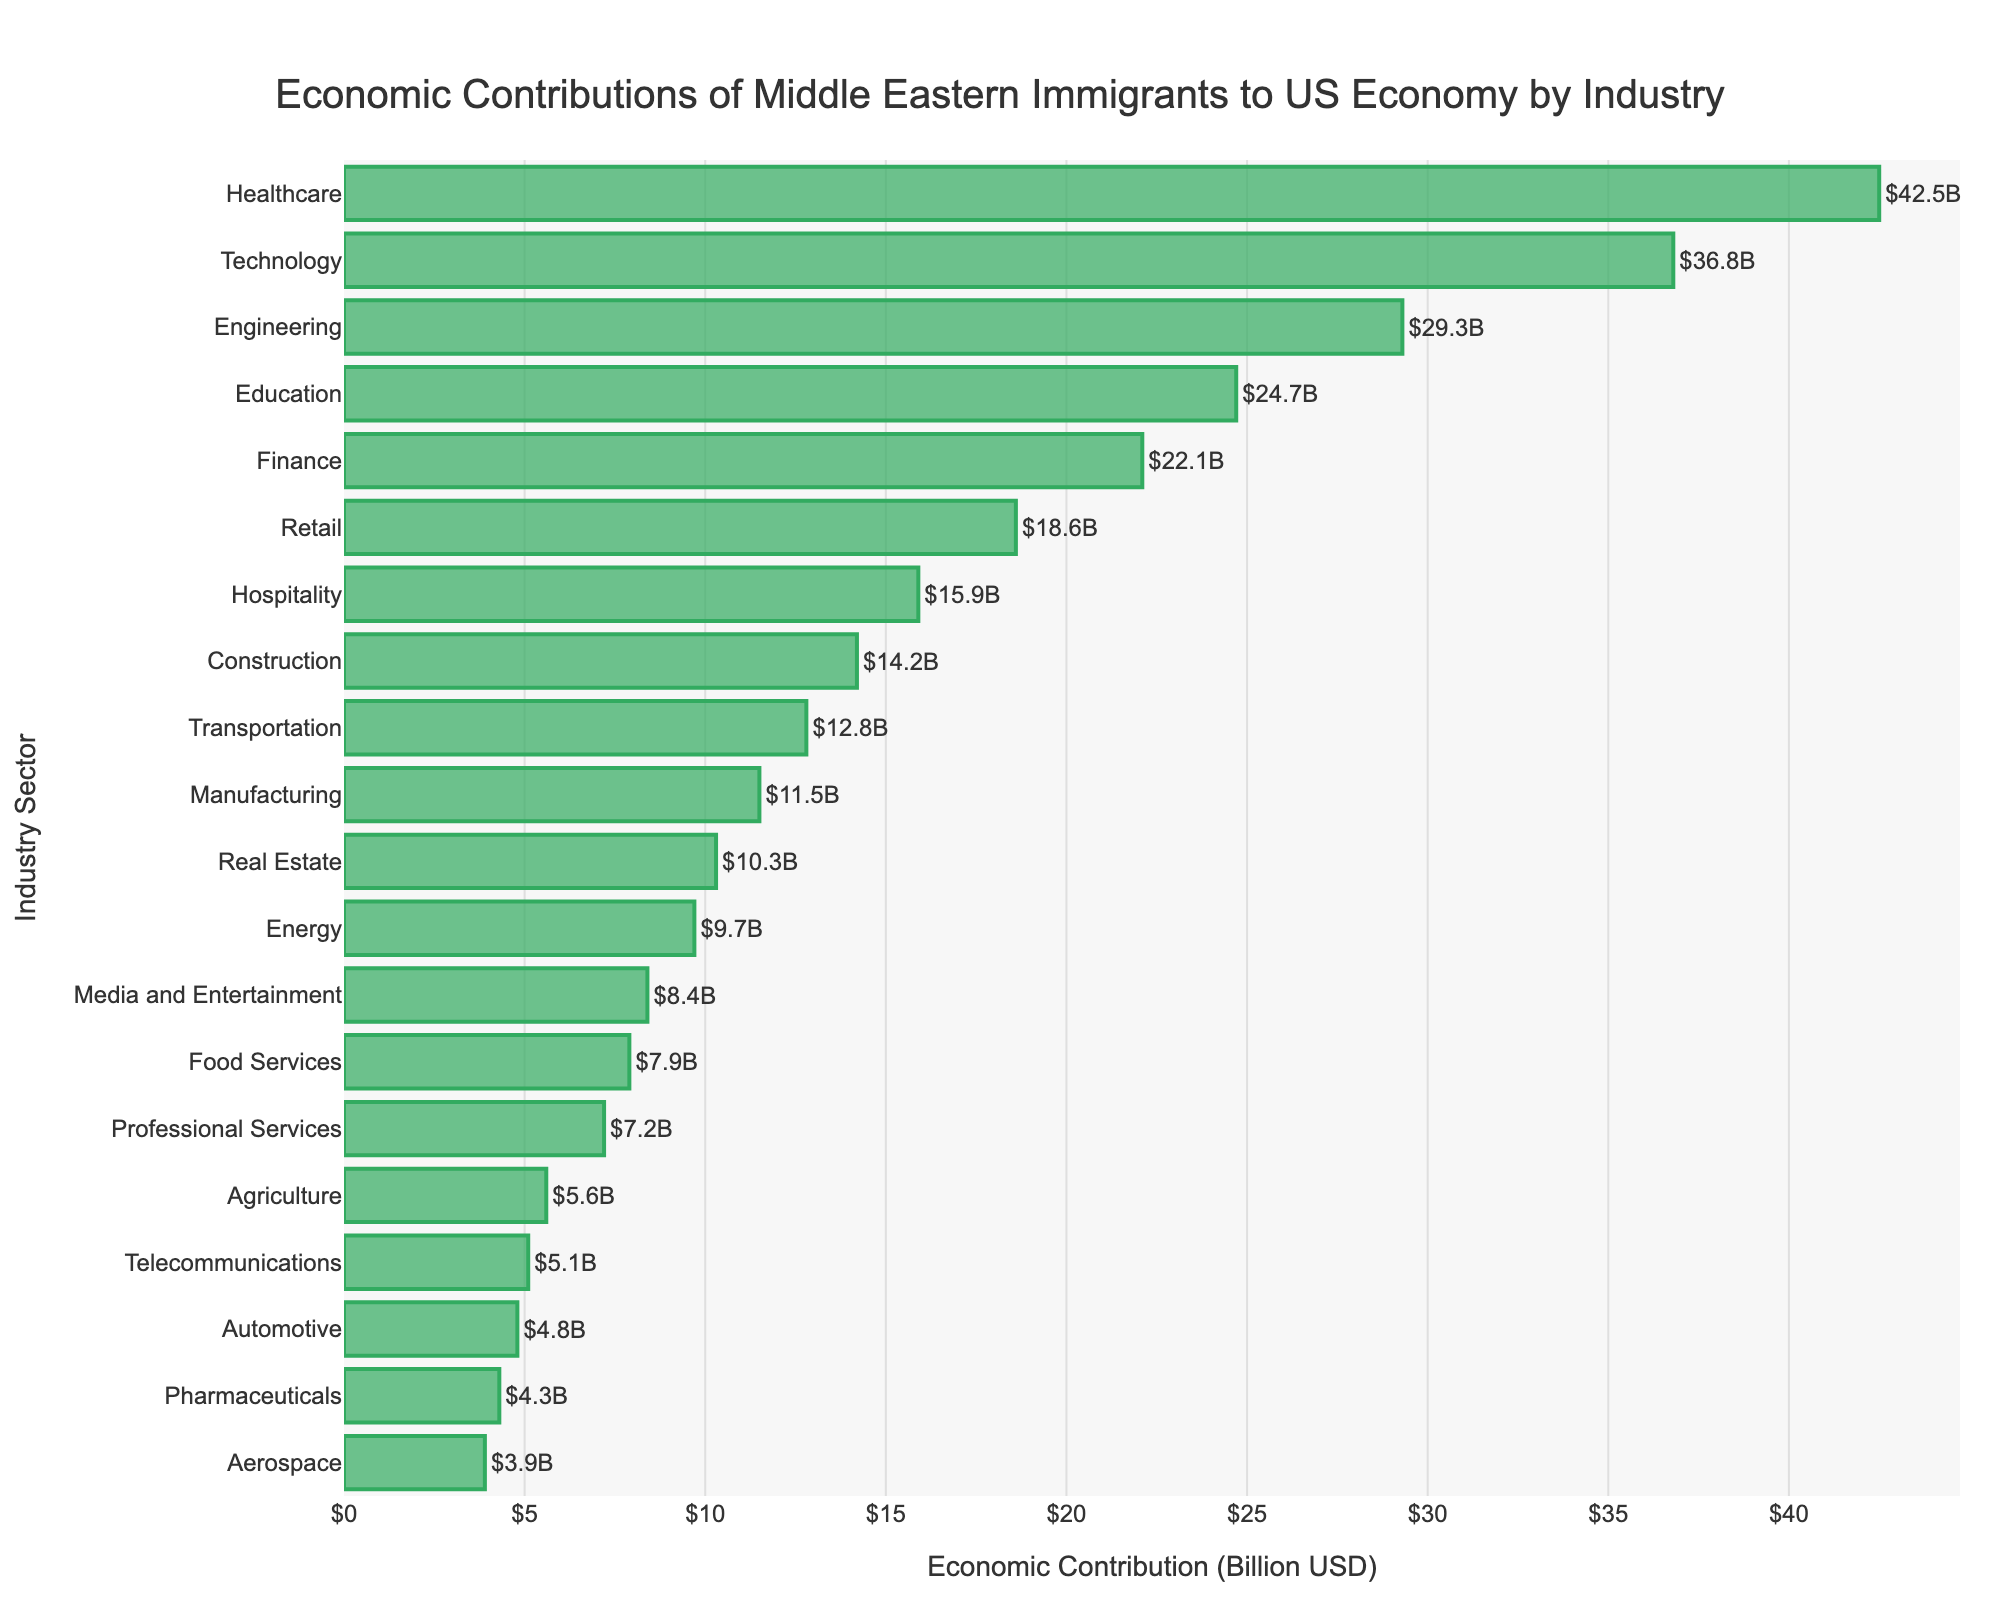Which industry has the highest economic contribution? The industry with the largest bar represents the highest economic contribution. The tallest bar corresponds to the Healthcare sector.
Answer: Healthcare What is the total economic contribution of the top three industries combined? The top three industries are Healthcare ($42.5B), Technology ($36.8B), and Engineering ($29.3B). Summing these values, $42.5B + $36.8B + $29.3B = $108.6B.
Answer: $108.6B Which industry has a higher economic contribution: Finance or Retail? By comparing the lengths of the bars corresponding to Finance and Retail, it is evident that Finance ($22.1B) is higher than Retail ($18.6B).
Answer: Finance What is the average economic contribution of the bottom five industries? The bottom five industries are Aerospace ($3.9B), Pharmaceuticals ($4.3B), Automotive ($4.8B), Telecommunications ($5.1B), and Agriculture ($5.6B). Sum these values: $3.9B + $4.3B + $4.8B + $5.1B + $5.6B = $23.7B. The average is $23.7B / 5 = $4.74B.
Answer: $4.74B Is the economic contribution of Technology greater than the combined contributions of Media and Entertainment and Food Services? The economic contribution of Technology is $36.8B. The combined contributions of Media and Entertainment ($8.4B) and Food Services ($7.9B) is $8.4B + $7.9B = $16.3B. Since $36.8B > $16.3B, Technology's contribution is greater.
Answer: Yes What is the difference in economic contributions between Education and Manufacturing? The economic contribution of Education is $24.7B and Manufacturing is $11.5B. The difference is $24.7B - $11.5B = $13.2B.
Answer: $13.2B How many industry sectors have an economic contribution of over $20 billion? By visually inspecting the bars longer than $20 billion, they are Healthcare, Technology, Engineering, Education, Finance. Therefore, there are 5 sectors.
Answer: 5 Which industry contributes more to the economy: Construction or Transportation? By comparing the bar lengths, Construction contributes $14.2B and Transportation contributes $12.8B. Construction's bar is longer.
Answer: Construction What is the ratio of the economic contribution of Hospitality to Professional Services? The economic contribution of Hospitality is $15.9B. Professional Services is $7.2B. The ratio is $15.9B / $7.2B = 2.208.
Answer: 2.2 What is the total economic contribution of all industries presented in the figure? Summing up the economic contributions of all industries: $42.5B + $36.8B + $29.3B + $24.7B + $22.1B + $18.6B + $15.9B + $14.2B + $12.8B + $11.5B + $10.3B + $9.7B + $8.4B + $7.9B + $7.2B + $5.6B + $5.1B + $4.8B + $4.3B + $3.9B = $299.6B.
Answer: $299.6B 